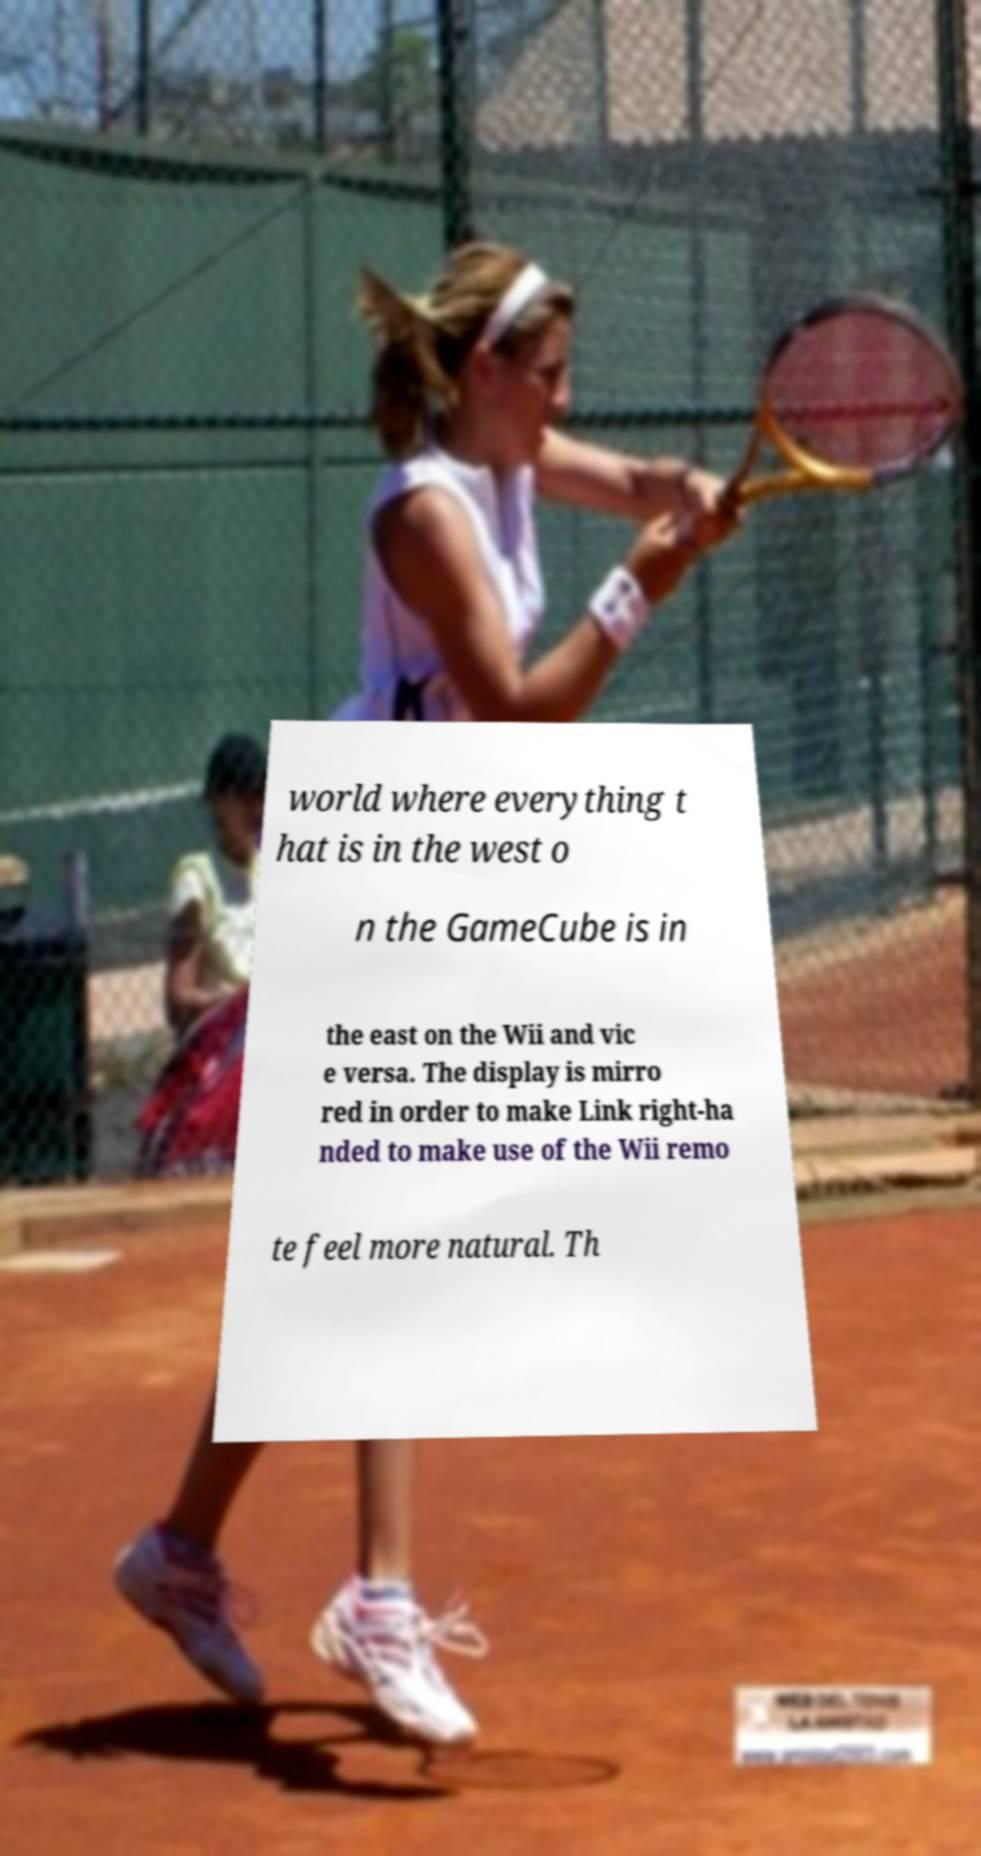Can you read and provide the text displayed in the image?This photo seems to have some interesting text. Can you extract and type it out for me? world where everything t hat is in the west o n the GameCube is in the east on the Wii and vic e versa. The display is mirro red in order to make Link right-ha nded to make use of the Wii remo te feel more natural. Th 